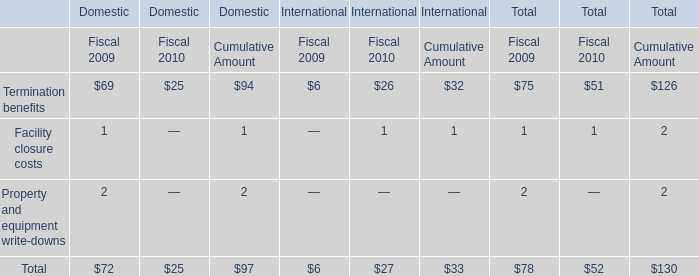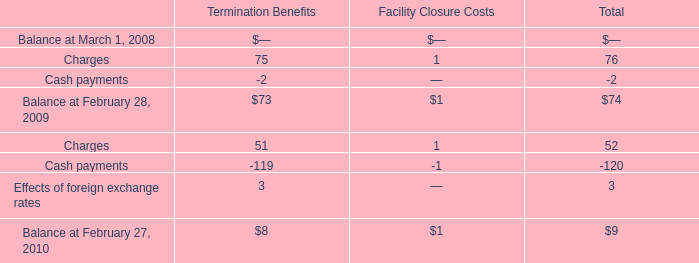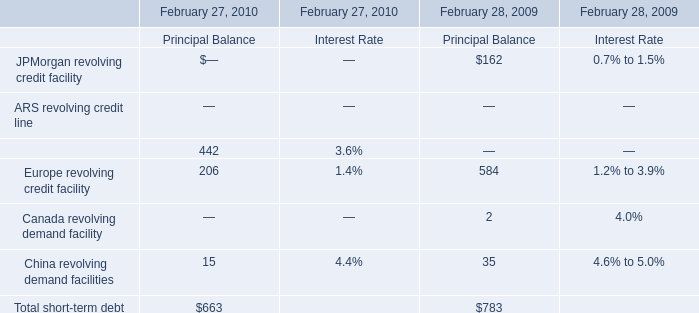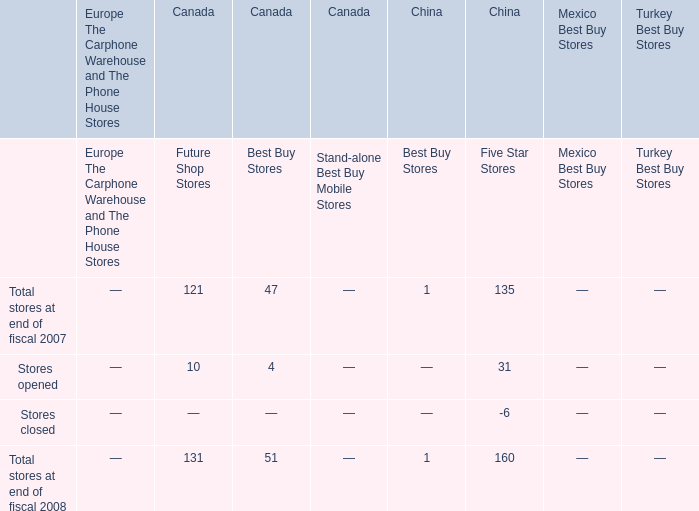What's the total amount of Charges of Termination Benefits, Charges of Facility Closure Costs, Cash payments of Termination Benefits and Cash payments of Facility Closure Costs in 2009? 
Computations: ((75 + 1) - 2)
Answer: 74.0. 